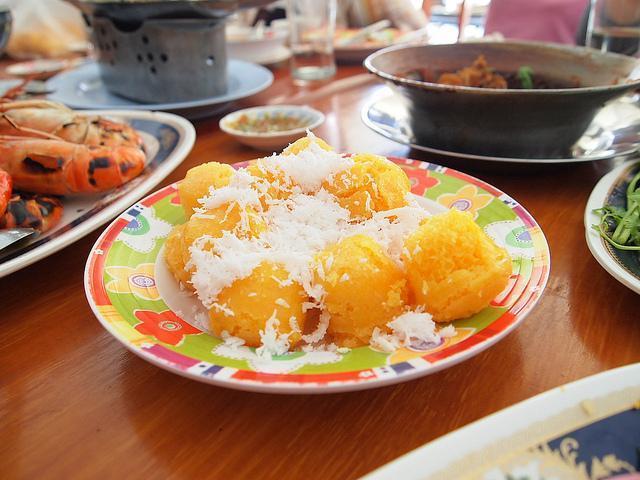How many cups are in the photo?
Give a very brief answer. 2. How many dining tables are there?
Give a very brief answer. 1. How many bowls can be seen?
Give a very brief answer. 2. 